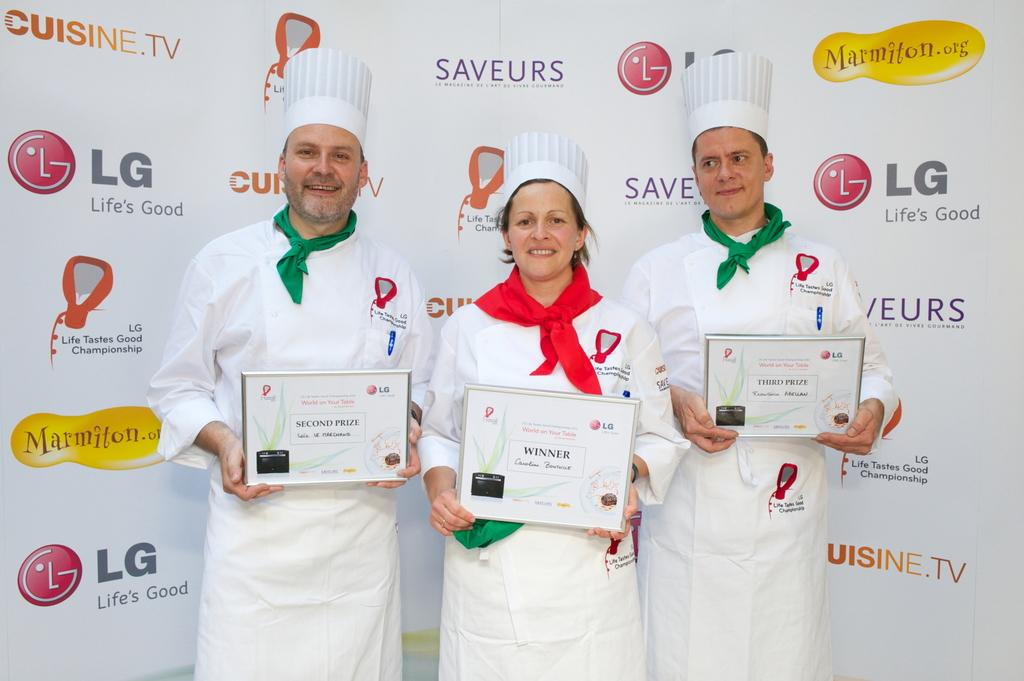What are the people in the image doing? The people in the image are holding objects. What can be seen in the background of the image? There is a poster with images and text in the background of the image. How does the kitty move around in the image? There is no kitty present in the image. 